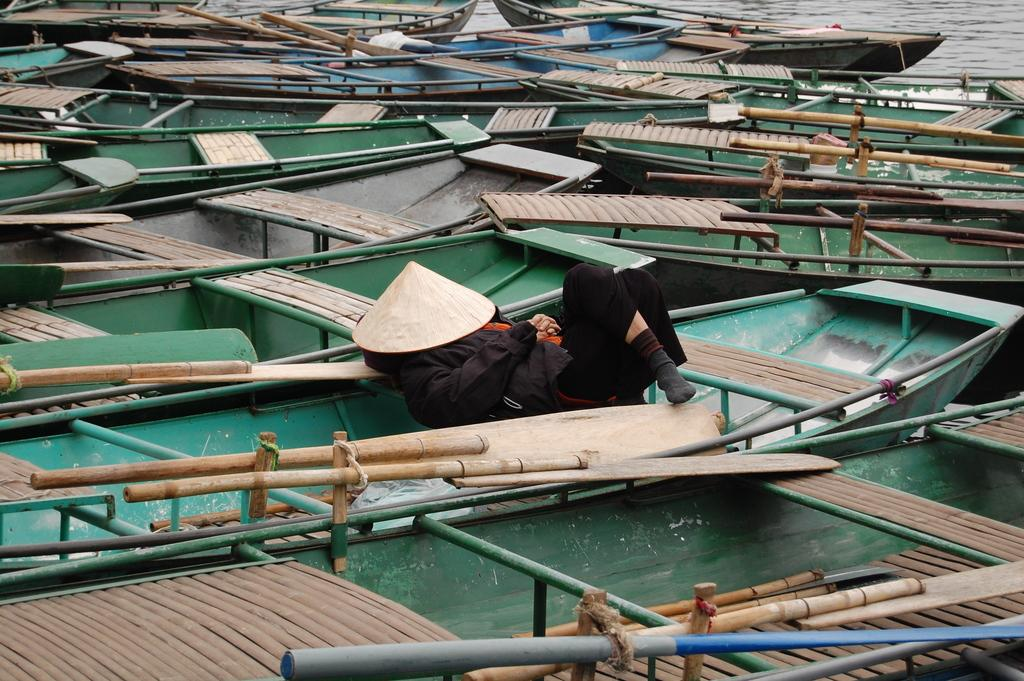What type of vehicles are in the water in the image? There are boats in the water in the image. What is the person on the boat doing? The person is lying on one of the boats. What might be used to propel the boats in the image? Paddles are visible in the image. Can you describe the behavior of the toad in the image? There is no toad present in the image. 